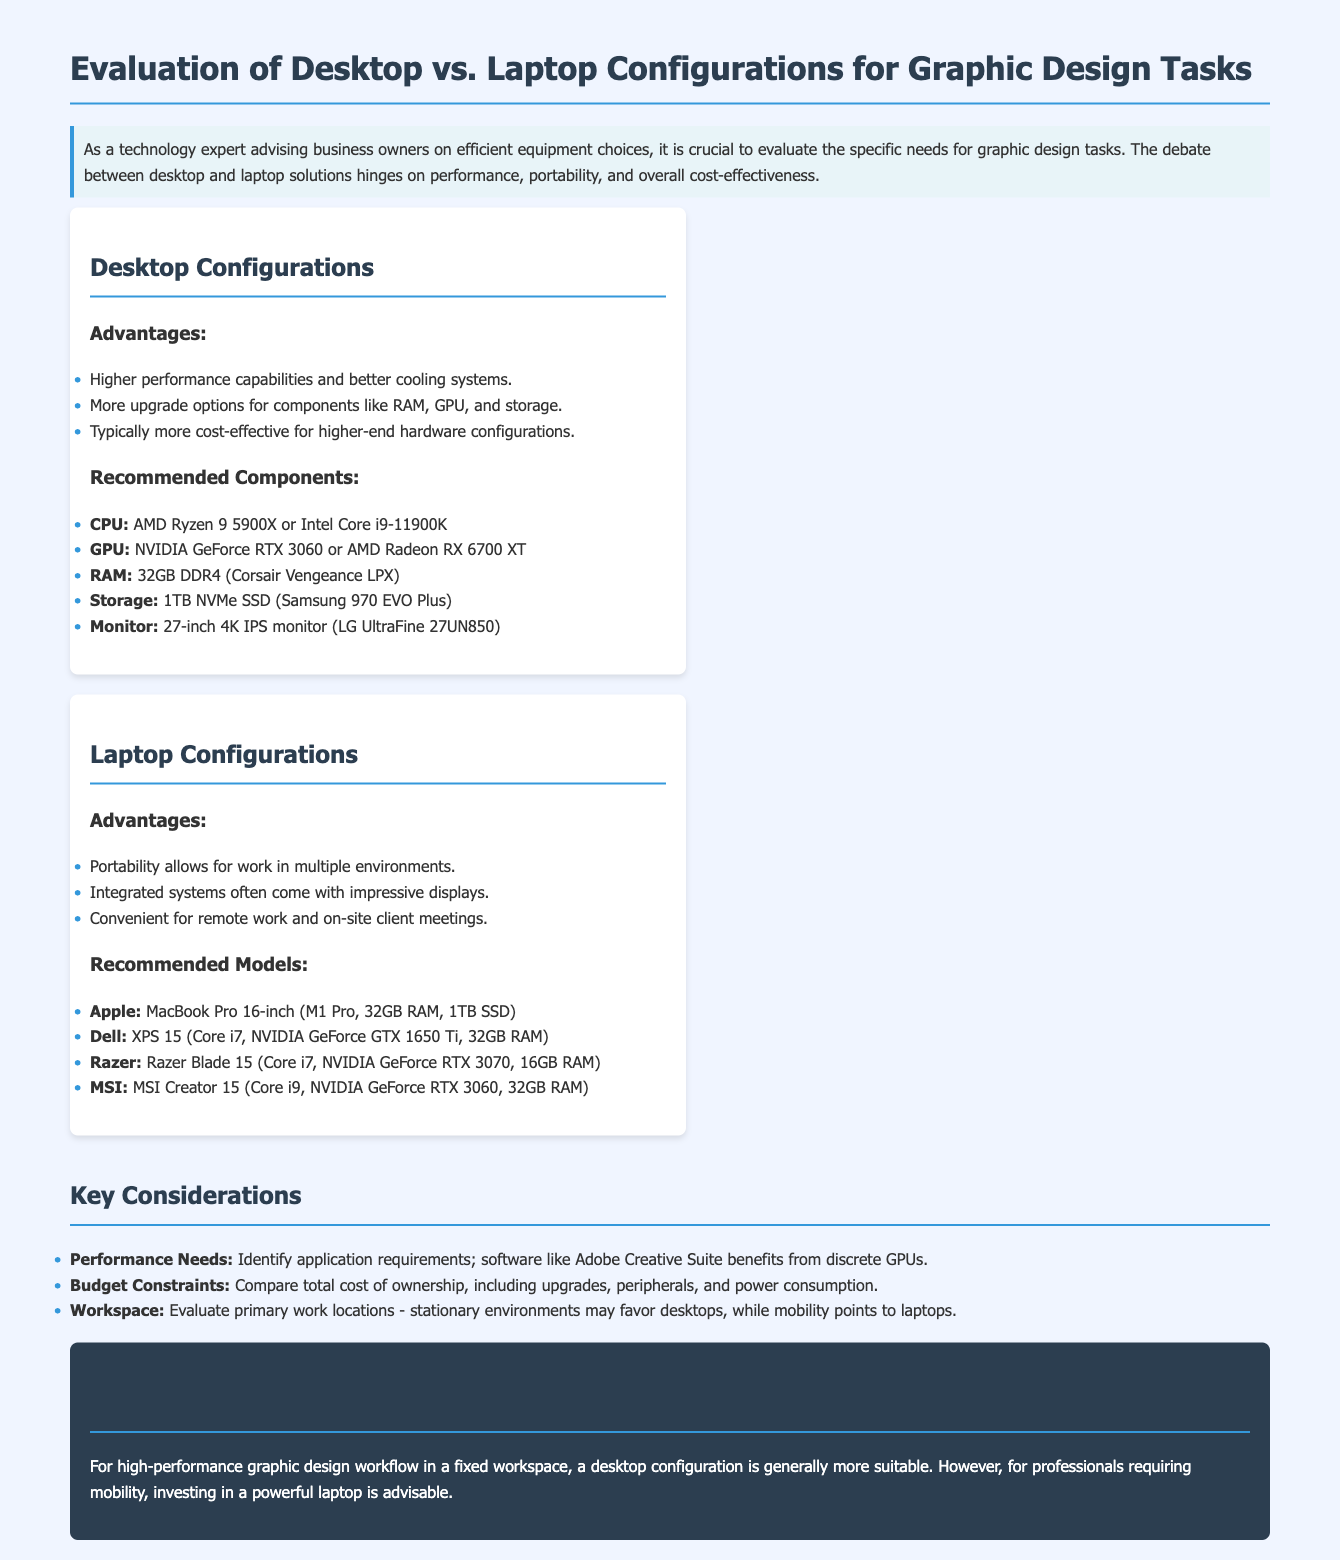what are the advantages of desktop configurations? The advantages of desktop configurations include higher performance capabilities, more upgrade options, and typically greater cost-effectiveness for higher-end hardware.
Answer: Higher performance, more upgrade options, cost-effective what component is recommended for RAM in desktop configurations? The recommended RAM for desktop configurations is specified in the document.
Answer: 32GB DDR4 which GPU is recommended for laptops? The document lists recommended GPUs for laptops, including different models.
Answer: NVIDIA GeForce GTX 1650 Ti what is the primary consideration when choosing between desktop and laptop? The key considerations involve performance needs, budget constraints, and workspace evaluation.
Answer: Performance needs, budget constraints, workspace what is the conclusion regarding desktop vs. laptop for graphic design? The conclusion summarizes the suitability of desktop and laptop for specific work settings, which is highlighted in the document.
Answer: Desktops for fixed workspace, laptops for mobility how many recommended laptop models are mentioned? The document lists several recommended laptop models for graphic design, indicating how many are included.
Answer: Four what is the recommended CPU for desktop configurations? The recommended CPU options for desktop configurations are mentioned clearly in the document.
Answer: AMD Ryzen 9 5900X or Intel Core i9-11900K for which type of work environments are laptops more suitable? The document specifies the advantages of laptops concerning their usability in various settings.
Answer: Remote work and on-site client meetings 